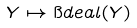<formula> <loc_0><loc_0><loc_500><loc_500>Y \mapsto \i d e a l ( Y )</formula> 